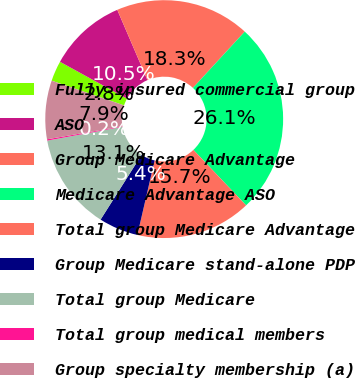<chart> <loc_0><loc_0><loc_500><loc_500><pie_chart><fcel>Fully-insured commercial group<fcel>ASO<fcel>Group Medicare Advantage<fcel>Medicare Advantage ASO<fcel>Total group Medicare Advantage<fcel>Group Medicare stand-alone PDP<fcel>Total group Medicare<fcel>Total group medical members<fcel>Group specialty membership (a)<nl><fcel>2.77%<fcel>10.54%<fcel>18.3%<fcel>26.07%<fcel>15.71%<fcel>5.36%<fcel>13.12%<fcel>0.18%<fcel>7.95%<nl></chart> 